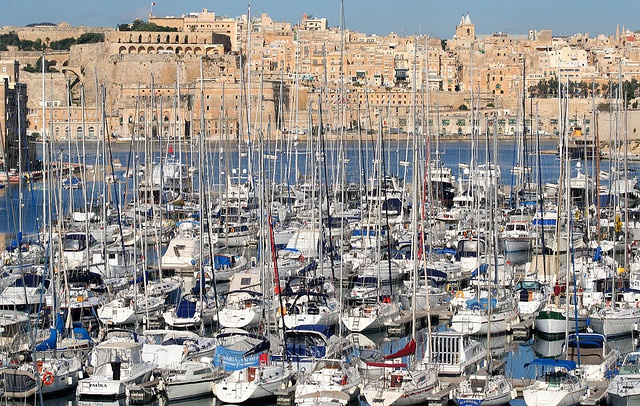Describe the objects in this image and their specific colors. I can see boat in darkgray, gray, lightgray, and black tones, boat in darkgray, lightgray, gray, and black tones, boat in darkgray, black, white, and gray tones, boat in darkgray, lightgray, gray, and black tones, and boat in darkgray, white, gray, and black tones in this image. 